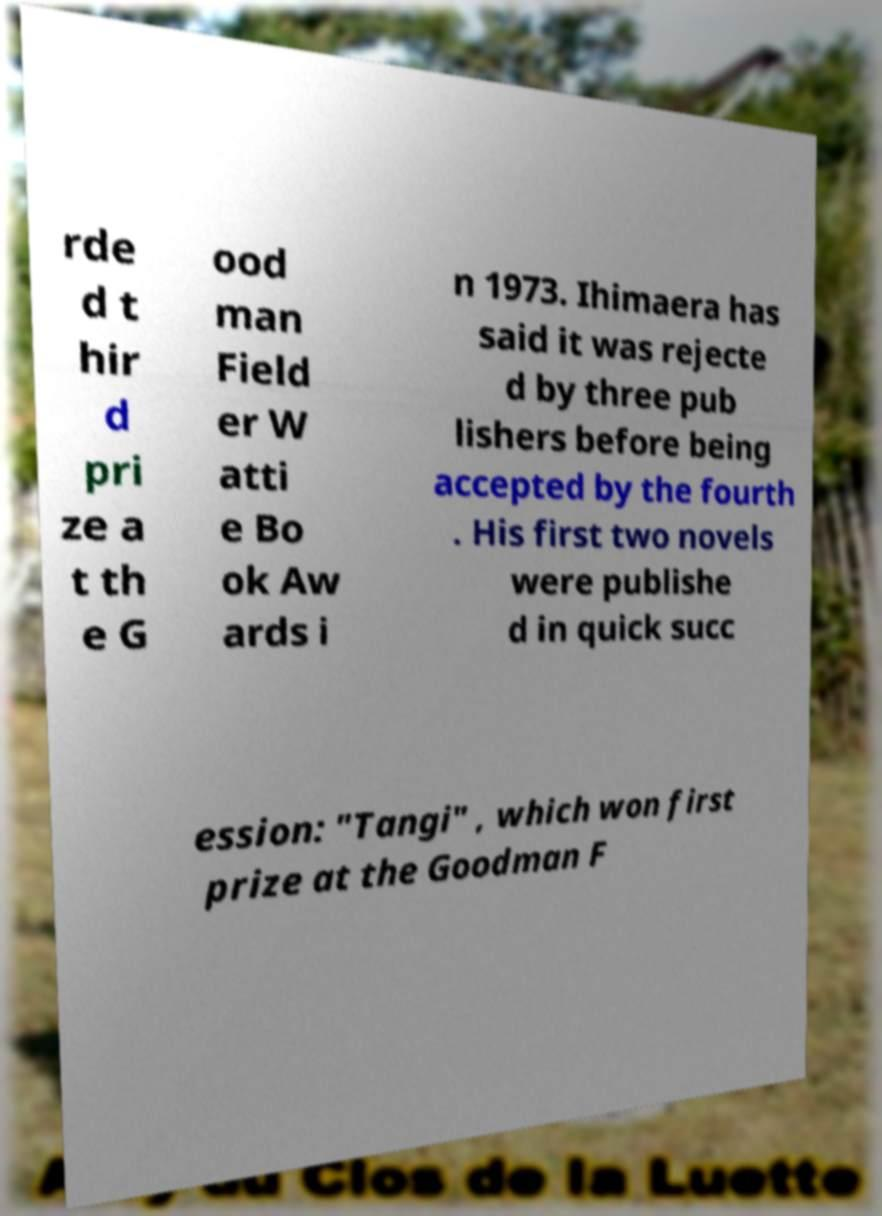What messages or text are displayed in this image? I need them in a readable, typed format. rde d t hir d pri ze a t th e G ood man Field er W atti e Bo ok Aw ards i n 1973. Ihimaera has said it was rejecte d by three pub lishers before being accepted by the fourth . His first two novels were publishe d in quick succ ession: "Tangi" , which won first prize at the Goodman F 